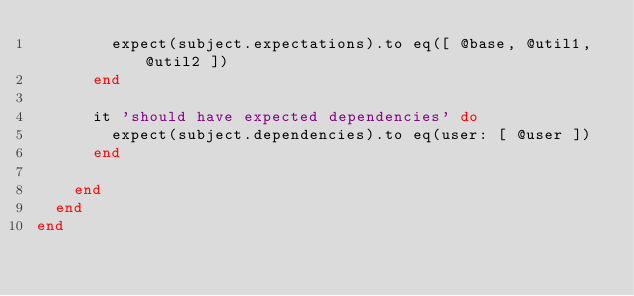<code> <loc_0><loc_0><loc_500><loc_500><_Ruby_>        expect(subject.expectations).to eq([ @base, @util1, @util2 ])
      end

      it 'should have expected dependencies' do
        expect(subject.dependencies).to eq(user: [ @user ])
      end

    end
  end
end
</code> 